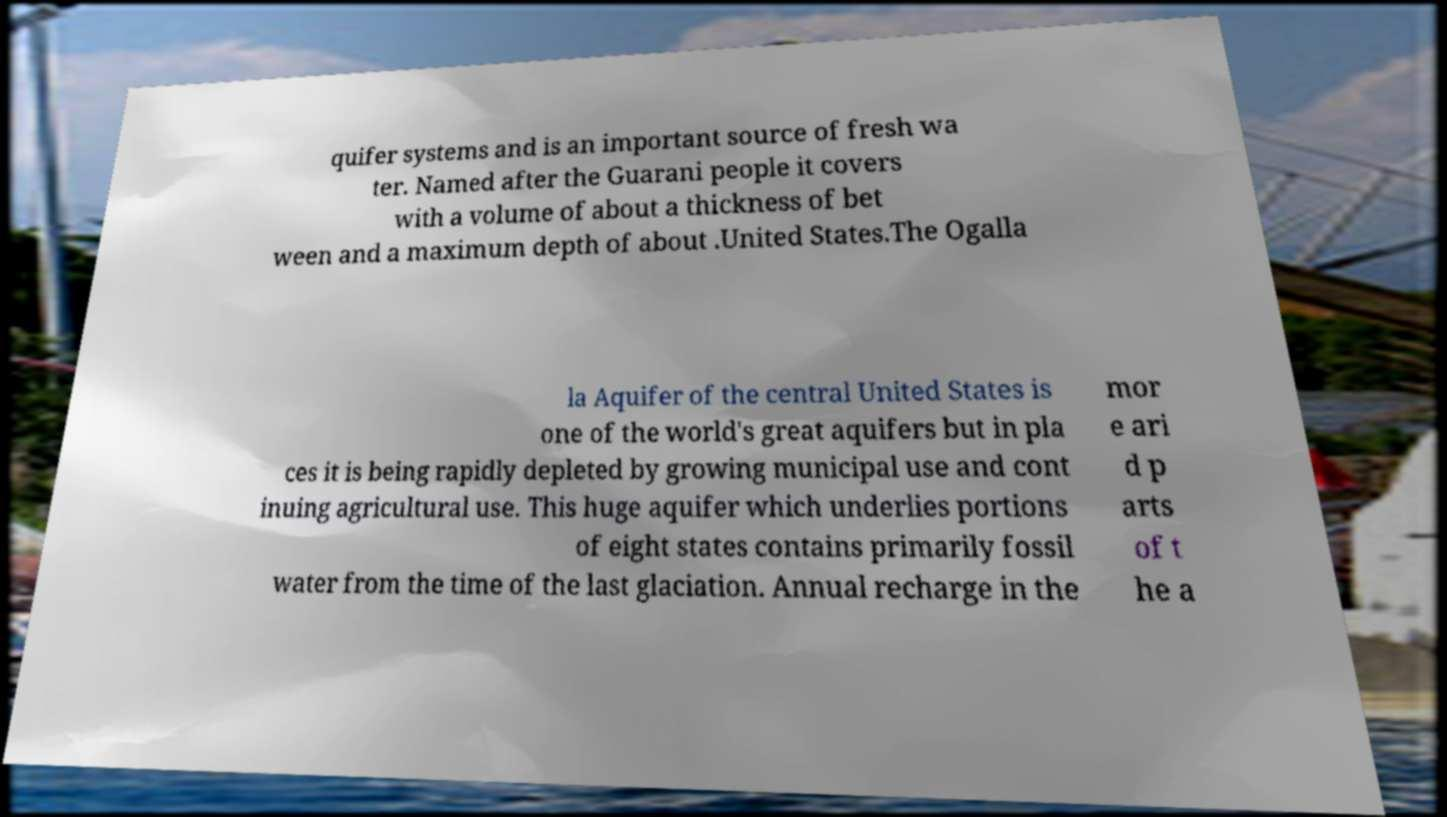What messages or text are displayed in this image? I need them in a readable, typed format. quifer systems and is an important source of fresh wa ter. Named after the Guarani people it covers with a volume of about a thickness of bet ween and a maximum depth of about .United States.The Ogalla la Aquifer of the central United States is one of the world's great aquifers but in pla ces it is being rapidly depleted by growing municipal use and cont inuing agricultural use. This huge aquifer which underlies portions of eight states contains primarily fossil water from the time of the last glaciation. Annual recharge in the mor e ari d p arts of t he a 